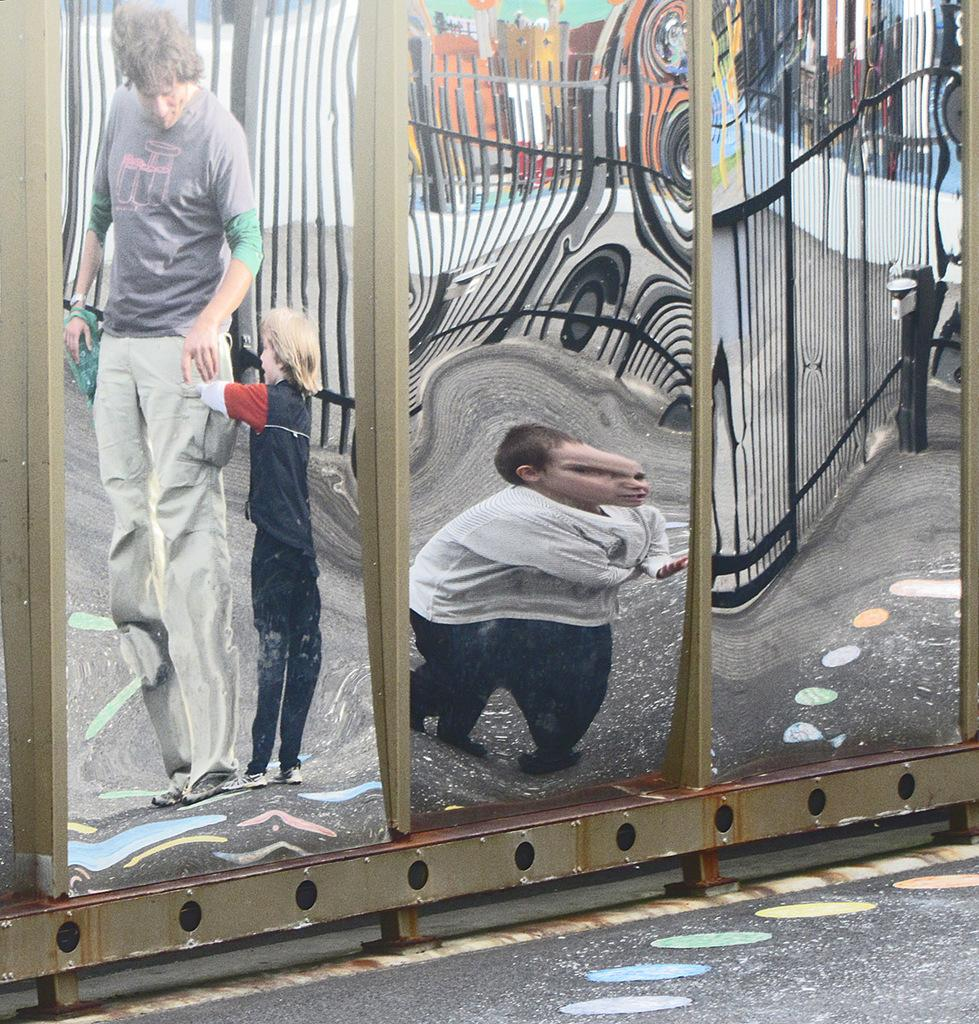What object in the image reflects images? There is a mirror in the image that reflects images. How many people can be seen in the mirror? The images of three people are reflected in the mirror. What else is being reflected in the mirror besides the people? A fence is being reflected on the mirror. What type of cable can be seen hanging from the tongue of one of the people in the image? There is no cable or tongue visible in the image; it only features a mirror reflecting three people and a fence. 